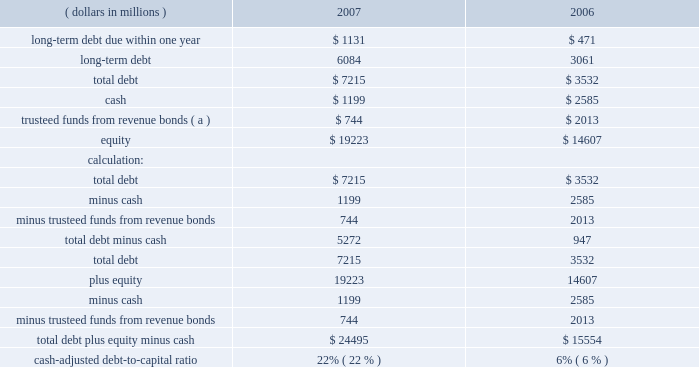Derivative instruments see quantitative and qualitative disclosures about market risk for a discussion of derivative instruments and associated market risk .
Dividends to stockholders dividends of $ 0.92 per common share or $ 637 million were paid during 2007 .
On january 27 , 2008 , our board of directors declared a dividend of $ 0.24 cents per share on our common stock , payable march 10 , 2008 , to stockholders of record at the close of business on february 20 , 2008 .
Liquidity and capital resources our main sources of liquidity and capital resources are internally generated cash flow from operations , committed credit facilities and access to both the debt and equity capital markets .
Our ability to access the debt capital market is supported by our investment grade credit ratings .
Our senior unsecured debt is currently rated investment grade by standard and poor 2019s corporation , moody 2019s investor services , inc .
And fitch ratings with ratings of bbb+ , baa1 , and bbb+ .
These ratings were reaffirmed in july 2007 after the western acquisition was announced .
Because of the alternatives available to us , including internally generated cash flow and potential asset sales , we believe that our short-term and long-term liquidity is adequate to fund operations , including our capital spending programs , stock repurchase program , repayment of debt maturities and any amounts that ultimately may be paid in connection with contingencies .
We have a committed $ 3.0 billion revolving credit facility with third-party financial institutions terminating in may 2012 .
At december 31 , 2007 , there were no borrowings against this facility and we had no commercial paper outstanding under our u.s .
Commercial paper program that is backed by this revolving credit facility .
On july 26 , 2007 , we filed a universal shelf registration statement with the securities and exchange commission , under which we , as a well-known seasoned issuer , have the ability to issue and sell an indeterminate amount of various types of debt and equity securities .
Our cash-adjusted debt-to-capital ratio ( total debt-minus-cash to total debt-plus-equity-minus-cash ) was 22 percent at december 31 , 2007 , compared to six percent at year-end 2006 as shown below .
This includes $ 498 million of debt that is serviced by united states steel .
( dollars in millions ) 2007 2006 .
( a ) following the issuance of the $ 1.0 billion of revenue bonds by the parish of st .
John the baptist , the proceeds were trusteed and will be disbursed to us upon our request for reimbursement of expenditures related to the garyville refinery expansion .
The trusteed funds are reflected as other noncurrent assets in the accompanying consolidated balance sheet as of december 31 , 2007. .
Did the company increase it's quarterly dividend rate from 2007 to 2008? 
Computations: (0.24 > (0.92 / 4))
Answer: yes. 